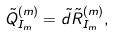Convert formula to latex. <formula><loc_0><loc_0><loc_500><loc_500>\tilde { Q } _ { I _ { m } } ^ { ( m ) } = \tilde { d } \tilde { R } _ { I _ { m } } ^ { ( m ) } ,</formula> 